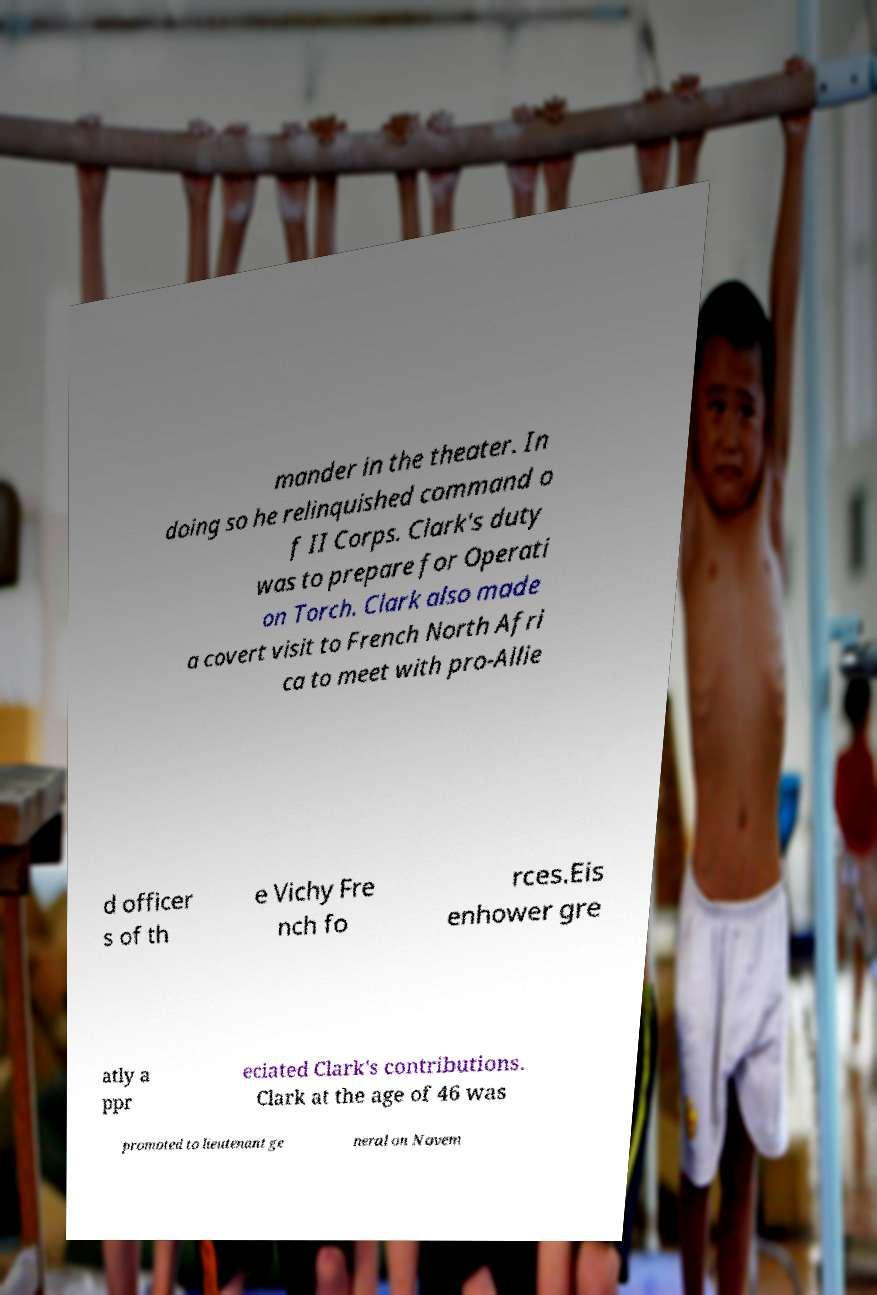Please identify and transcribe the text found in this image. mander in the theater. In doing so he relinquished command o f II Corps. Clark's duty was to prepare for Operati on Torch. Clark also made a covert visit to French North Afri ca to meet with pro-Allie d officer s of th e Vichy Fre nch fo rces.Eis enhower gre atly a ppr eciated Clark's contributions. Clark at the age of 46 was promoted to lieutenant ge neral on Novem 